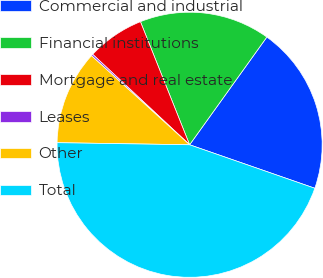<chart> <loc_0><loc_0><loc_500><loc_500><pie_chart><fcel>Commercial and industrial<fcel>Financial institutions<fcel>Mortgage and real estate<fcel>Leases<fcel>Other<fcel>Total<nl><fcel>20.42%<fcel>15.95%<fcel>7.0%<fcel>0.22%<fcel>11.48%<fcel>44.93%<nl></chart> 